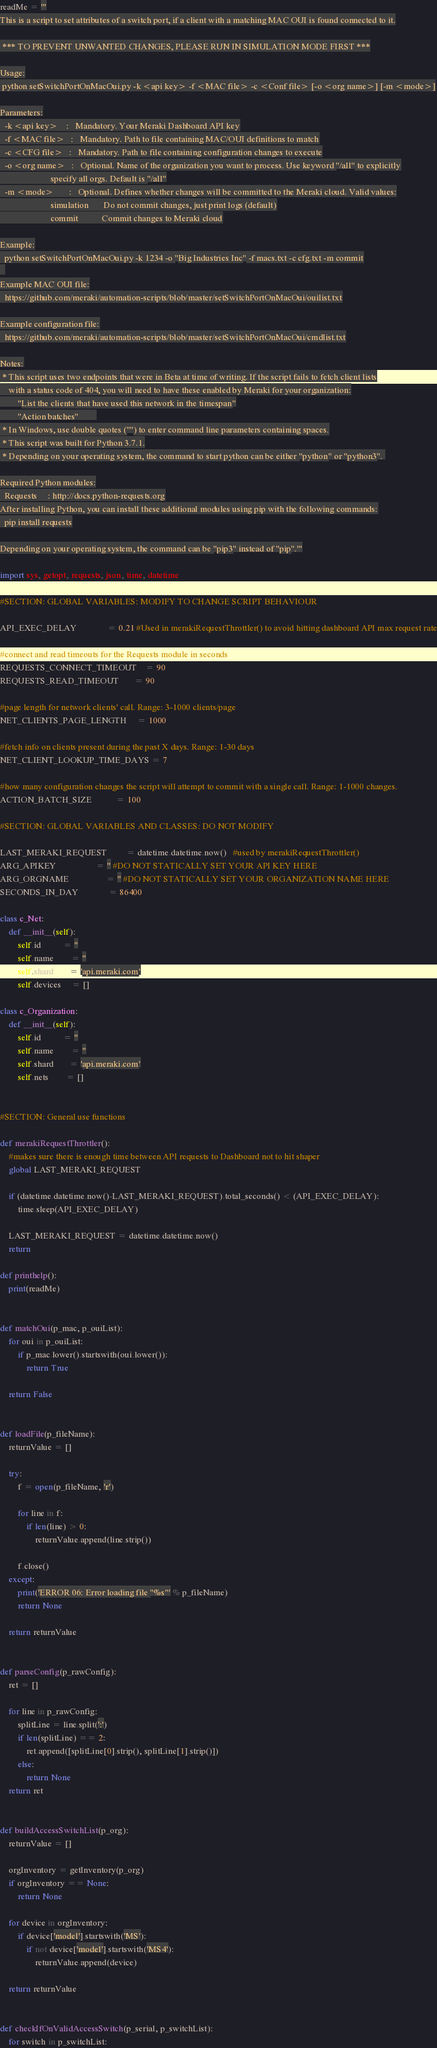Convert code to text. <code><loc_0><loc_0><loc_500><loc_500><_Python_>readMe = '''
This is a script to set attributes of a switch port, if a client with a matching MAC OUI is found connected to it.

 *** TO PREVENT UNWANTED CHANGES, PLEASE RUN IN SIMULATION MODE FIRST ***

Usage:
 python setSwitchPortOnMacOui.py -k <api key> -f <MAC file> -c <Conf file> [-o <org name>] [-m <mode>]

Parameters:
  -k <api key>    :   Mandatory. Your Meraki Dashboard API key
  -f <MAC file>   :   Mandatory. Path to file containing MAC/OUI definitions to match
  -c <CFG file>   :   Mandatory. Path to file containing configuration changes to execute
  -o <org name>   :   Optional. Name of the organization you want to process. Use keyword "/all" to explicitly
                       specify all orgs. Default is "/all"
  -m <mode>       :   Optional. Defines whether changes will be committed to the Meraki cloud. Valid values:
                       simulation       Do not commit changes, just print logs (default)
                       commit           Commit changes to Meraki cloud

Example:
  python setSwitchPortOnMacOui.py -k 1234 -o "Big Industries Inc" -f macs.txt -c cfg.txt -m commit
  
Example MAC OUI file:
  https://github.com/meraki/automation-scripts/blob/master/setSwitchPortOnMacOui/ouilist.txt

Example configuration file:
  https://github.com/meraki/automation-scripts/blob/master/setSwitchPortOnMacOui/cmdlist.txt

Notes:
 * This script uses two endpoints that were in Beta at time of writing. If the script fails to fetch client lists
    with a status code of 404, you will need to have these enabled by Meraki for your organization:
        "List the clients that have used this network in the timespan"
        "Action batches"        
 * In Windows, use double quotes ("") to enter command line parameters containing spaces.
 * This script was built for Python 3.7.1.
 * Depending on your operating system, the command to start python can be either "python" or "python3". 

Required Python modules:
  Requests     : http://docs.python-requests.org
After installing Python, you can install these additional modules using pip with the following commands:
  pip install requests

Depending on your operating system, the command can be "pip3" instead of "pip".'''

import sys, getopt, requests, json, time, datetime

#SECTION: GLOBAL VARIABLES: MODIFY TO CHANGE SCRIPT BEHAVIOUR

API_EXEC_DELAY              = 0.21 #Used in merakiRequestThrottler() to avoid hitting dashboard API max request rate

#connect and read timeouts for the Requests module in seconds
REQUESTS_CONNECT_TIMEOUT    = 90
REQUESTS_READ_TIMEOUT       = 90

#page length for network clients' call. Range: 3-1000 clients/page
NET_CLIENTS_PAGE_LENGTH     = 1000

#fetch info on clients present during the past X days. Range: 1-30 days
NET_CLIENT_LOOKUP_TIME_DAYS = 7

#how many configuration changes the script will attempt to commit with a single call. Range: 1-1000 changes.
ACTION_BATCH_SIZE           = 100

#SECTION: GLOBAL VARIABLES AND CLASSES: DO NOT MODIFY

LAST_MERAKI_REQUEST         = datetime.datetime.now()   #used by merakiRequestThrottler()
ARG_APIKEY                  = '' #DO NOT STATICALLY SET YOUR API KEY HERE
ARG_ORGNAME                 = '' #DO NOT STATICALLY SET YOUR ORGANIZATION NAME HERE
SECONDS_IN_DAY              = 86400
           
class c_Net:
    def __init__(self):
        self.id          = ''
        self.name        = ''
        self.shard       = 'api.meraki.com'
        self.devices     = []
        
class c_Organization:
    def __init__(self):
        self.id          = ''
        self.name        = ''
        self.shard       = 'api.meraki.com'
        self.nets        = []
        
        
#SECTION: General use functions

def merakiRequestThrottler():
    #makes sure there is enough time between API requests to Dashboard not to hit shaper
    global LAST_MERAKI_REQUEST
    
    if (datetime.datetime.now()-LAST_MERAKI_REQUEST).total_seconds() < (API_EXEC_DELAY):
        time.sleep(API_EXEC_DELAY)
    
    LAST_MERAKI_REQUEST = datetime.datetime.now()
    return
    
def printhelp():
    print(readMe)
    
    
def matchOui(p_mac, p_ouiList):
    for oui in p_ouiList:
        if p_mac.lower().startswith(oui.lower()):
            return True

    return False
    
    
def loadFile(p_fileName):
    returnValue = []

    try:
        f = open(p_fileName, 'r')
    
        for line in f:
            if len(line) > 0:
                returnValue.append(line.strip())
            
        f.close()
    except:
        print('ERROR 06: Error loading file "%s"' % p_fileName)
        return None     
        
    return returnValue
    
    
def parseConfig(p_rawConfig):
    ret = []

    for line in p_rawConfig:
        splitLine = line.split(':')
        if len(splitLine) == 2:
            ret.append([splitLine[0].strip(), splitLine[1].strip()])
        else:
            return None
    return ret
    
    
def buildAccessSwitchList(p_org):
    returnValue = []

    orgInventory = getInventory(p_org)
    if orgInventory == None:
        return None
            
    for device in orgInventory:
        if device['model'].startswith('MS'):
            if not device['model'].startswith('MS4'):
                returnValue.append(device)
                
    return returnValue


def checkIfOnValidAccessSwitch(p_serial, p_switchList):
    for switch in p_switchList:</code> 